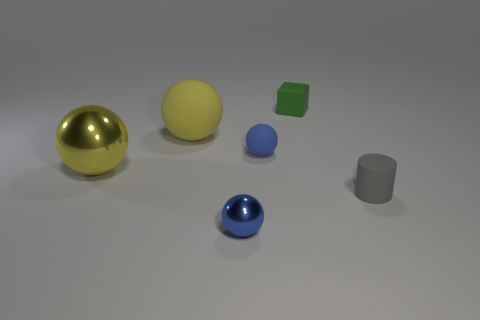There is another large sphere that is the same color as the big metallic ball; what is it made of?
Provide a succinct answer. Rubber. Is there anything else that is the same material as the gray cylinder?
Your answer should be compact. Yes. Are there any green cylinders that have the same material as the tiny gray cylinder?
Provide a succinct answer. No. There is another sphere that is the same size as the yellow rubber sphere; what is it made of?
Provide a short and direct response. Metal. What number of metal things are the same shape as the gray rubber thing?
Offer a terse response. 0. What size is the yellow sphere that is the same material as the green thing?
Offer a very short reply. Large. What material is the thing that is behind the tiny rubber sphere and right of the blue metal sphere?
Offer a terse response. Rubber. How many blocks have the same size as the yellow metallic thing?
Your response must be concise. 0. There is another big thing that is the same shape as the big matte object; what is it made of?
Make the answer very short. Metal. What number of objects are blue balls that are on the left side of the gray matte cylinder or small rubber objects that are to the left of the tiny green thing?
Your response must be concise. 2. 